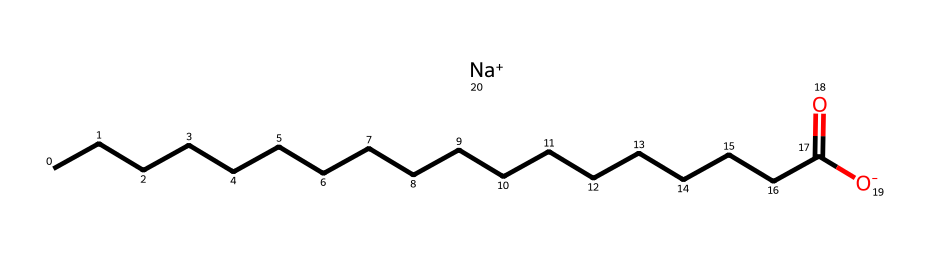What is the main functional group present in this molecule? The molecule includes a carboxylate group indicated by the segment "CCCCCCCCCCCCCCCCCC(=O)[O-]," with (-O[-]) showing the deprotonation of the carboxylic acid, forming the carboxylate.
Answer: carboxylate How many carbon atoms are present in the structure? Counting the "C" symbols in the long hydrocarbon chain "CCCCCCCCCCCCCCCCCC" provides a total of 18 carbon atoms.
Answer: 18 What type of sodium compound is formed in this structure? The presence of "Na+" indicates that sodium is forming a sodium salt, particularly a sodium carboxylate salt due to the reaction of sodium with the carboxylic acid group.
Answer: sodium carboxylate What is the role of lye in the production of this soap? Lye, which contains sodium hydroxide, reacts with the fatty acids from tallow to saponify them, producing soap through the formation of fatty acid salts, like the one represented.
Answer: saponification Is this molecule polar or nonpolar? The presence of the carboxylate group adds polarity to the molecule, although the long hydrocarbon chain contributes nonpolar characteristics, making it amphiphilic.
Answer: amphiphilic What property of this chemical allows it to act as a detergent? Its amphiphilic nature, where the nonpolar tail interacts with oils and the polar head interacts with water, allows it to emulsify fats and function as a detergent.
Answer: amphiphilic nature 